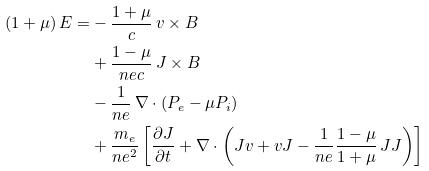Convert formula to latex. <formula><loc_0><loc_0><loc_500><loc_500>\left ( 1 + \mu \right ) E = & - \frac { 1 + \mu } { c } \, v \times B \\ & + \frac { 1 - \mu } { n e c } \, J \times B \\ & - \frac { 1 } { n e } \, \nabla \cdot \left ( P _ { e } - \mu P _ { i } \right ) \\ & + \frac { m _ { e } } { n e ^ { 2 } } \left [ \frac { \partial J } { \partial t } + \nabla \cdot \left ( J v + v J - \frac { 1 } { n e } \frac { 1 - \mu } { 1 + \mu } \, J J \right ) \right ]</formula> 